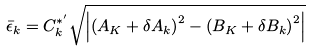<formula> <loc_0><loc_0><loc_500><loc_500>\bar { \epsilon } _ { k } = C _ { k } ^ { * ^ { \prime } } \sqrt { \left | \left ( A _ { K } + \delta A _ { k } \right ) ^ { 2 } - \left ( B _ { K } + \delta B _ { k } \right ) ^ { 2 } \right | }</formula> 